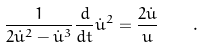<formula> <loc_0><loc_0><loc_500><loc_500>\frac { 1 } { 2 \dot { u } ^ { 2 } - \dot { u } ^ { 3 } } \frac { d } { d t } \dot { u } ^ { 2 } = \frac { 2 \dot { u } } { u } \quad .</formula> 